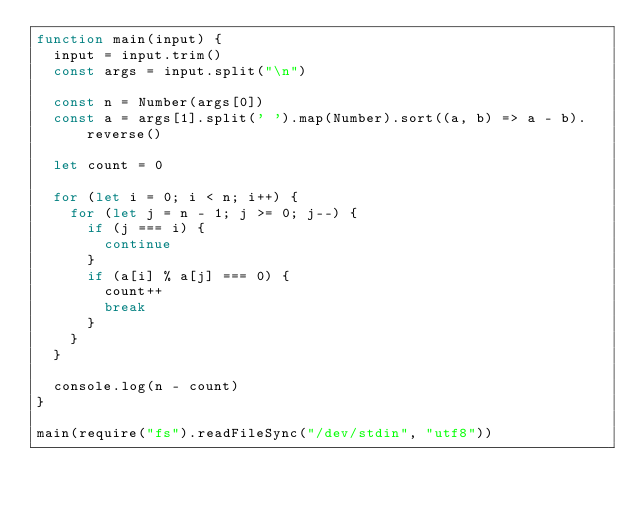Convert code to text. <code><loc_0><loc_0><loc_500><loc_500><_JavaScript_>function main(input) {
  input = input.trim()
  const args = input.split("\n")

  const n = Number(args[0])
  const a = args[1].split(' ').map(Number).sort((a, b) => a - b).reverse()

  let count = 0

  for (let i = 0; i < n; i++) {
    for (let j = n - 1; j >= 0; j--) {
      if (j === i) {
        continue
      }
      if (a[i] % a[j] === 0) {
        count++
        break
      }
    }
  }

  console.log(n - count)
}

main(require("fs").readFileSync("/dev/stdin", "utf8"))
</code> 